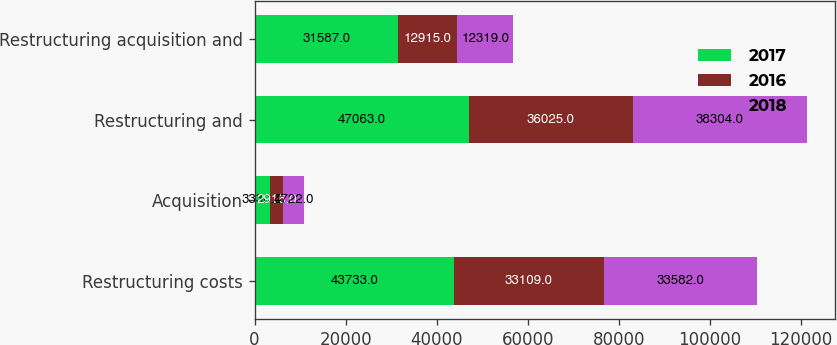Convert chart to OTSL. <chart><loc_0><loc_0><loc_500><loc_500><stacked_bar_chart><ecel><fcel>Restructuring costs<fcel>Acquisition<fcel>Restructuring and<fcel>Restructuring acquisition and<nl><fcel>2017<fcel>43733<fcel>3330<fcel>47063<fcel>31587<nl><fcel>2016<fcel>33109<fcel>2916<fcel>36025<fcel>12915<nl><fcel>2018<fcel>33582<fcel>4722<fcel>38304<fcel>12319<nl></chart> 